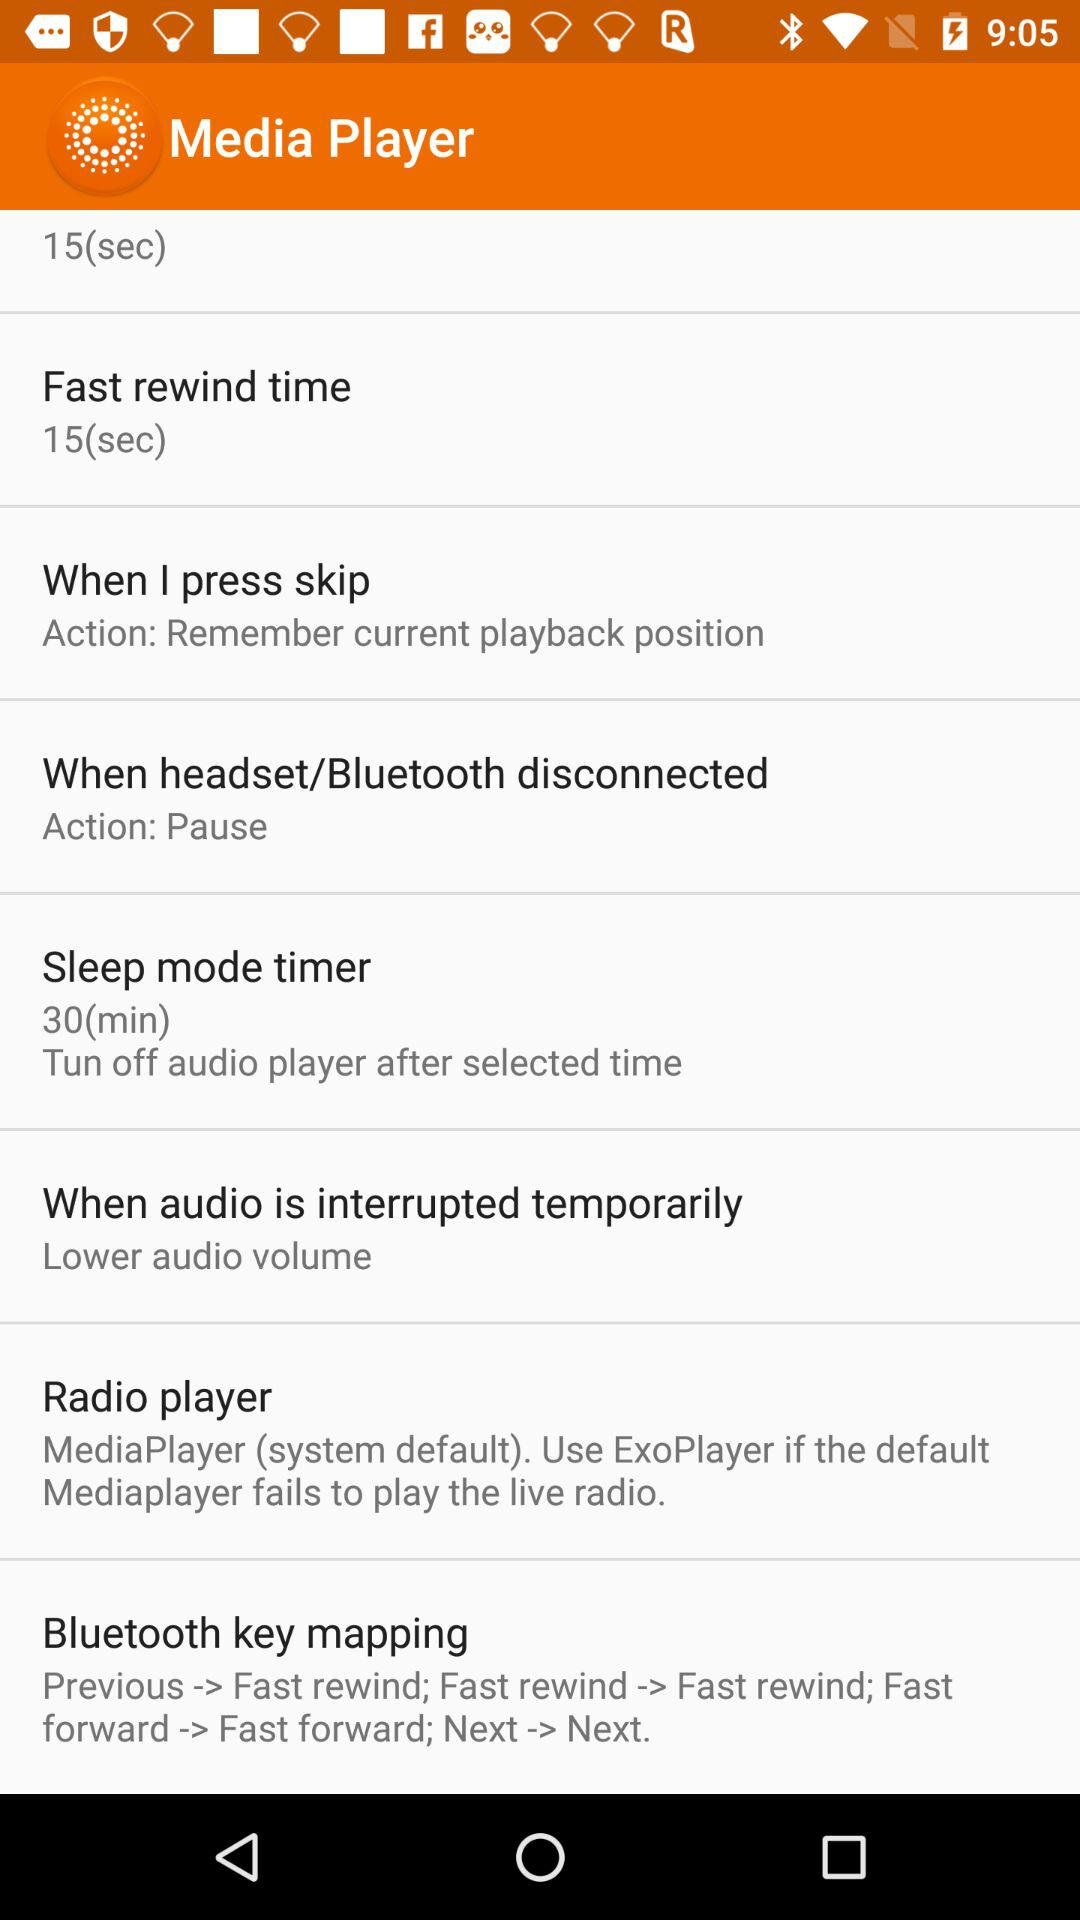What is the time duration for a sleep mode timer? The time duration is 30 minutes. 